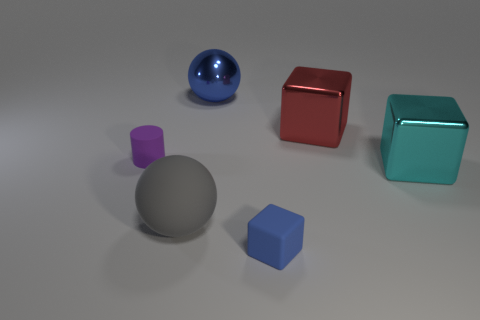Add 4 large red rubber blocks. How many objects exist? 10 Subtract all spheres. How many objects are left? 4 Add 3 big red objects. How many big red objects are left? 4 Add 3 cubes. How many cubes exist? 6 Subtract 0 cyan cylinders. How many objects are left? 6 Subtract all tiny purple cylinders. Subtract all big cyan rubber blocks. How many objects are left? 5 